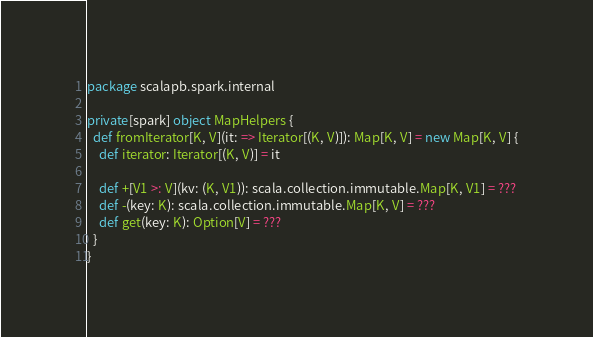Convert code to text. <code><loc_0><loc_0><loc_500><loc_500><_Scala_>package scalapb.spark.internal

private[spark] object MapHelpers {
  def fromIterator[K, V](it: => Iterator[(K, V)]): Map[K, V] = new Map[K, V] {
    def iterator: Iterator[(K, V)] = it

    def +[V1 >: V](kv: (K, V1)): scala.collection.immutable.Map[K, V1] = ???
    def -(key: K): scala.collection.immutable.Map[K, V] = ???
    def get(key: K): Option[V] = ???
  }
}
</code> 